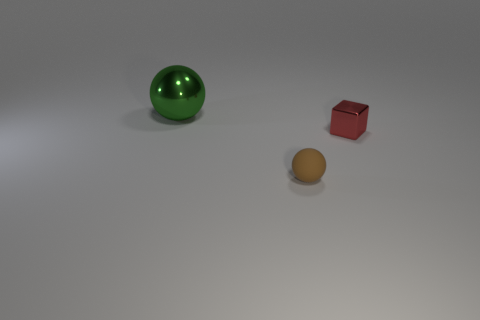Is there any other thing that has the same shape as the small shiny thing?
Your answer should be compact. No. Is there any other thing that is the same size as the green thing?
Keep it short and to the point. No. What number of objects are tiny red shiny blocks behind the small rubber thing or small green cylinders?
Your answer should be compact. 1. What number of brown objects are either rubber objects or large shiny things?
Give a very brief answer. 1. What number of other things are there of the same color as the shiny block?
Make the answer very short. 0. Is the number of large green balls to the left of the large metallic object less than the number of small brown objects?
Your answer should be very brief. Yes. What color is the sphere that is in front of the shiny thing that is on the left side of the ball that is to the right of the green shiny object?
Offer a very short reply. Brown. Is there any other thing that has the same material as the big thing?
Provide a short and direct response. Yes. The other brown thing that is the same shape as the large metallic object is what size?
Make the answer very short. Small. Are there fewer tiny brown spheres that are left of the tiny red metallic object than spheres that are on the left side of the green shiny thing?
Provide a short and direct response. No. 